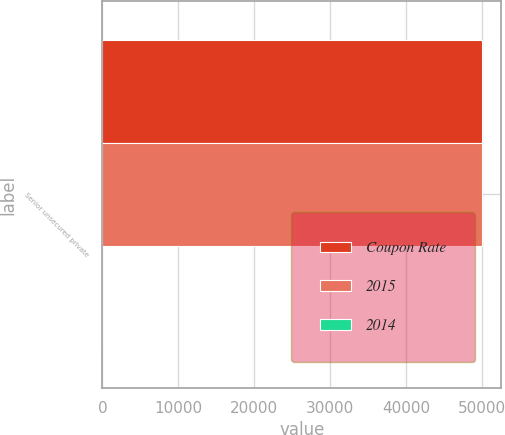Convert chart. <chart><loc_0><loc_0><loc_500><loc_500><stacked_bar_chart><ecel><fcel>Senior unsecured private<nl><fcel>Coupon Rate<fcel>50000<nl><fcel>2015<fcel>50000<nl><fcel>2014<fcel>4.37<nl></chart> 